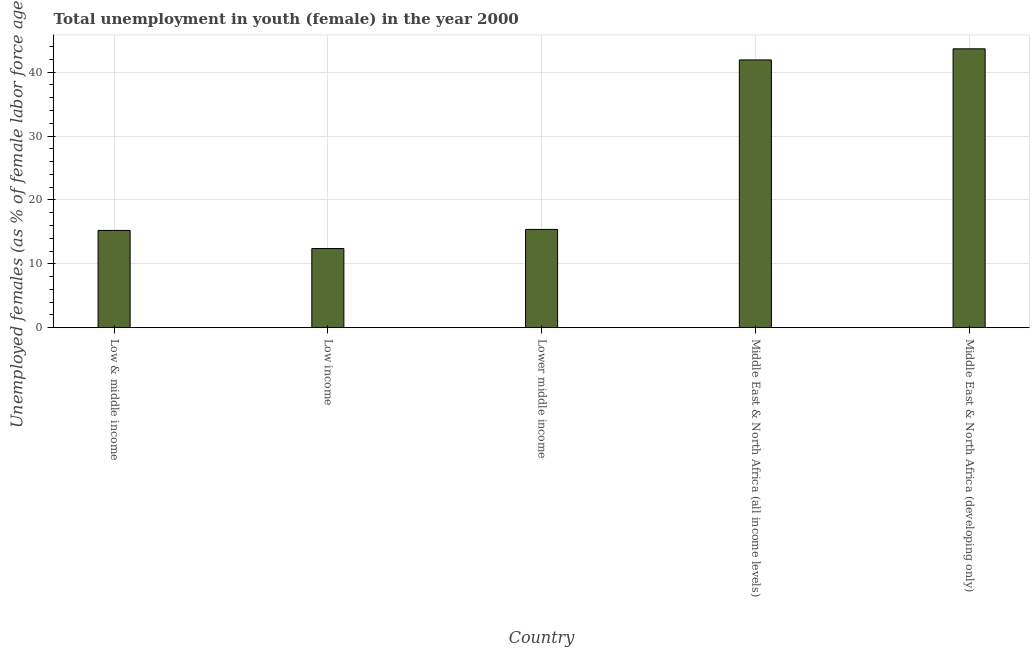Does the graph contain any zero values?
Provide a short and direct response. No. Does the graph contain grids?
Your answer should be compact. Yes. What is the title of the graph?
Provide a short and direct response. Total unemployment in youth (female) in the year 2000. What is the label or title of the Y-axis?
Keep it short and to the point. Unemployed females (as % of female labor force ages 15-24). What is the unemployed female youth population in Lower middle income?
Ensure brevity in your answer.  15.38. Across all countries, what is the maximum unemployed female youth population?
Provide a succinct answer. 43.66. Across all countries, what is the minimum unemployed female youth population?
Provide a succinct answer. 12.39. In which country was the unemployed female youth population maximum?
Your answer should be compact. Middle East & North Africa (developing only). In which country was the unemployed female youth population minimum?
Ensure brevity in your answer.  Low income. What is the sum of the unemployed female youth population?
Make the answer very short. 128.59. What is the difference between the unemployed female youth population in Low & middle income and Low income?
Give a very brief answer. 2.83. What is the average unemployed female youth population per country?
Provide a short and direct response. 25.72. What is the median unemployed female youth population?
Ensure brevity in your answer.  15.38. In how many countries, is the unemployed female youth population greater than 2 %?
Give a very brief answer. 5. What is the ratio of the unemployed female youth population in Low income to that in Lower middle income?
Your answer should be compact. 0.81. Is the difference between the unemployed female youth population in Low & middle income and Middle East & North Africa (all income levels) greater than the difference between any two countries?
Your answer should be very brief. No. What is the difference between the highest and the second highest unemployed female youth population?
Give a very brief answer. 1.74. What is the difference between the highest and the lowest unemployed female youth population?
Offer a very short reply. 31.27. Are all the bars in the graph horizontal?
Your answer should be compact. No. How many countries are there in the graph?
Provide a short and direct response. 5. What is the difference between two consecutive major ticks on the Y-axis?
Give a very brief answer. 10. What is the Unemployed females (as % of female labor force ages 15-24) in Low & middle income?
Provide a short and direct response. 15.22. What is the Unemployed females (as % of female labor force ages 15-24) of Low income?
Provide a short and direct response. 12.39. What is the Unemployed females (as % of female labor force ages 15-24) in Lower middle income?
Offer a terse response. 15.38. What is the Unemployed females (as % of female labor force ages 15-24) of Middle East & North Africa (all income levels)?
Provide a succinct answer. 41.93. What is the Unemployed females (as % of female labor force ages 15-24) of Middle East & North Africa (developing only)?
Provide a short and direct response. 43.66. What is the difference between the Unemployed females (as % of female labor force ages 15-24) in Low & middle income and Low income?
Your response must be concise. 2.83. What is the difference between the Unemployed females (as % of female labor force ages 15-24) in Low & middle income and Lower middle income?
Offer a terse response. -0.16. What is the difference between the Unemployed females (as % of female labor force ages 15-24) in Low & middle income and Middle East & North Africa (all income levels)?
Offer a very short reply. -26.7. What is the difference between the Unemployed females (as % of female labor force ages 15-24) in Low & middle income and Middle East & North Africa (developing only)?
Offer a very short reply. -28.44. What is the difference between the Unemployed females (as % of female labor force ages 15-24) in Low income and Lower middle income?
Provide a short and direct response. -2.99. What is the difference between the Unemployed females (as % of female labor force ages 15-24) in Low income and Middle East & North Africa (all income levels)?
Offer a very short reply. -29.53. What is the difference between the Unemployed females (as % of female labor force ages 15-24) in Low income and Middle East & North Africa (developing only)?
Provide a succinct answer. -31.27. What is the difference between the Unemployed females (as % of female labor force ages 15-24) in Lower middle income and Middle East & North Africa (all income levels)?
Your response must be concise. -26.54. What is the difference between the Unemployed females (as % of female labor force ages 15-24) in Lower middle income and Middle East & North Africa (developing only)?
Ensure brevity in your answer.  -28.28. What is the difference between the Unemployed females (as % of female labor force ages 15-24) in Middle East & North Africa (all income levels) and Middle East & North Africa (developing only)?
Give a very brief answer. -1.74. What is the ratio of the Unemployed females (as % of female labor force ages 15-24) in Low & middle income to that in Low income?
Offer a terse response. 1.23. What is the ratio of the Unemployed females (as % of female labor force ages 15-24) in Low & middle income to that in Middle East & North Africa (all income levels)?
Your response must be concise. 0.36. What is the ratio of the Unemployed females (as % of female labor force ages 15-24) in Low & middle income to that in Middle East & North Africa (developing only)?
Provide a short and direct response. 0.35. What is the ratio of the Unemployed females (as % of female labor force ages 15-24) in Low income to that in Lower middle income?
Provide a short and direct response. 0.81. What is the ratio of the Unemployed females (as % of female labor force ages 15-24) in Low income to that in Middle East & North Africa (all income levels)?
Make the answer very short. 0.3. What is the ratio of the Unemployed females (as % of female labor force ages 15-24) in Low income to that in Middle East & North Africa (developing only)?
Ensure brevity in your answer.  0.28. What is the ratio of the Unemployed females (as % of female labor force ages 15-24) in Lower middle income to that in Middle East & North Africa (all income levels)?
Provide a succinct answer. 0.37. What is the ratio of the Unemployed females (as % of female labor force ages 15-24) in Lower middle income to that in Middle East & North Africa (developing only)?
Your answer should be very brief. 0.35. 